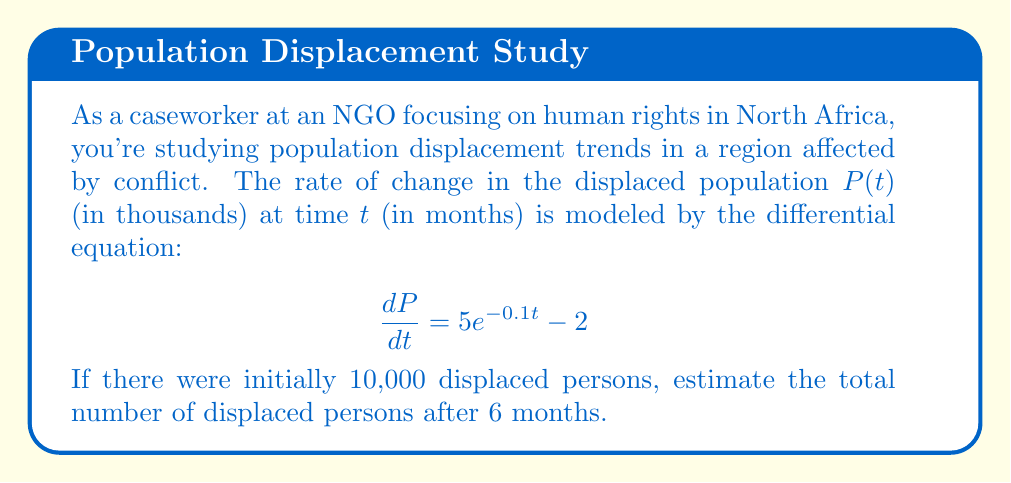Provide a solution to this math problem. 1) We start with the differential equation:
   $$\frac{dP}{dt} = 5e^{-0.1t} - 2$$

2) To find $P(t)$, we need to integrate both sides:
   $$P(t) = \int (5e^{-0.1t} - 2) dt$$

3) Integrate term by term:
   $$P(t) = -50e^{-0.1t} - 2t + C$$

4) Use the initial condition $P(0) = 10$ to find $C$:
   $$10 = -50e^{0} - 2(0) + C$$
   $$10 = -50 + C$$
   $$C = 60$$

5) So, the general solution is:
   $$P(t) = -50e^{-0.1t} - 2t + 60$$

6) To find $P(6)$, substitute $t = 6$:
   $$P(6) = -50e^{-0.1(6)} - 2(6) + 60$$
   $$= -50e^{-0.6} - 12 + 60$$
   $$= -50(0.5488) - 12 + 60$$
   $$= -27.44 - 12 + 60$$
   $$= 20.56$$

7) Since $P(t)$ is in thousands, multiply by 1000:
   $$20.56 * 1000 = 20,560$$
Answer: 20,560 persons 